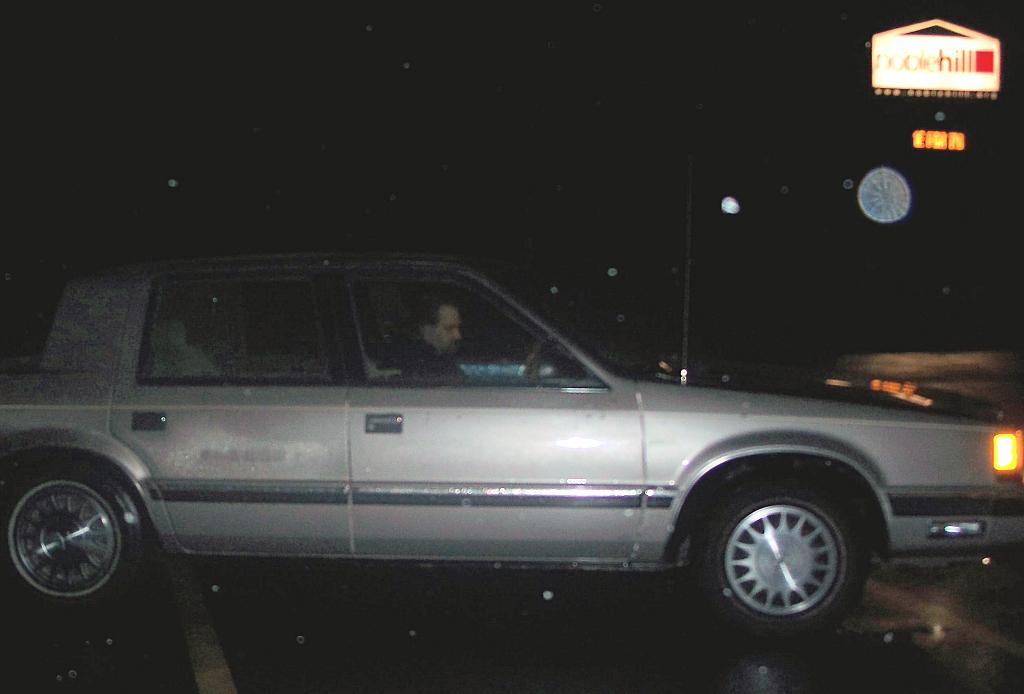What is the main subject of the image? There is a car in the image. Is there anyone inside the car? Yes, there is a person in the car. What can be seen in the background of the image? There is a hoarding in the background of the image. What feature of the car is visible in the image? There is an indicator visible in the image. What type of arithmetic problem is the person in the car solving in the image? There is no indication in the image that the person in the car is solving an arithmetic problem. 